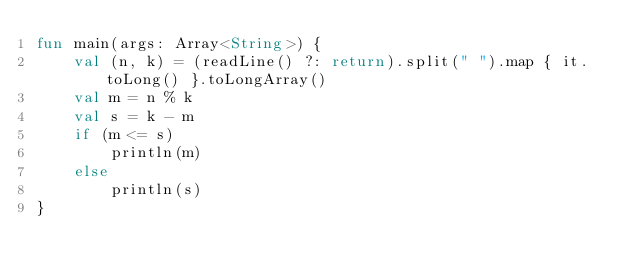<code> <loc_0><loc_0><loc_500><loc_500><_Kotlin_>fun main(args: Array<String>) {
    val (n, k) = (readLine() ?: return).split(" ").map { it.toLong() }.toLongArray()
    val m = n % k
    val s = k - m
    if (m <= s)
        println(m)
    else
        println(s)
}</code> 